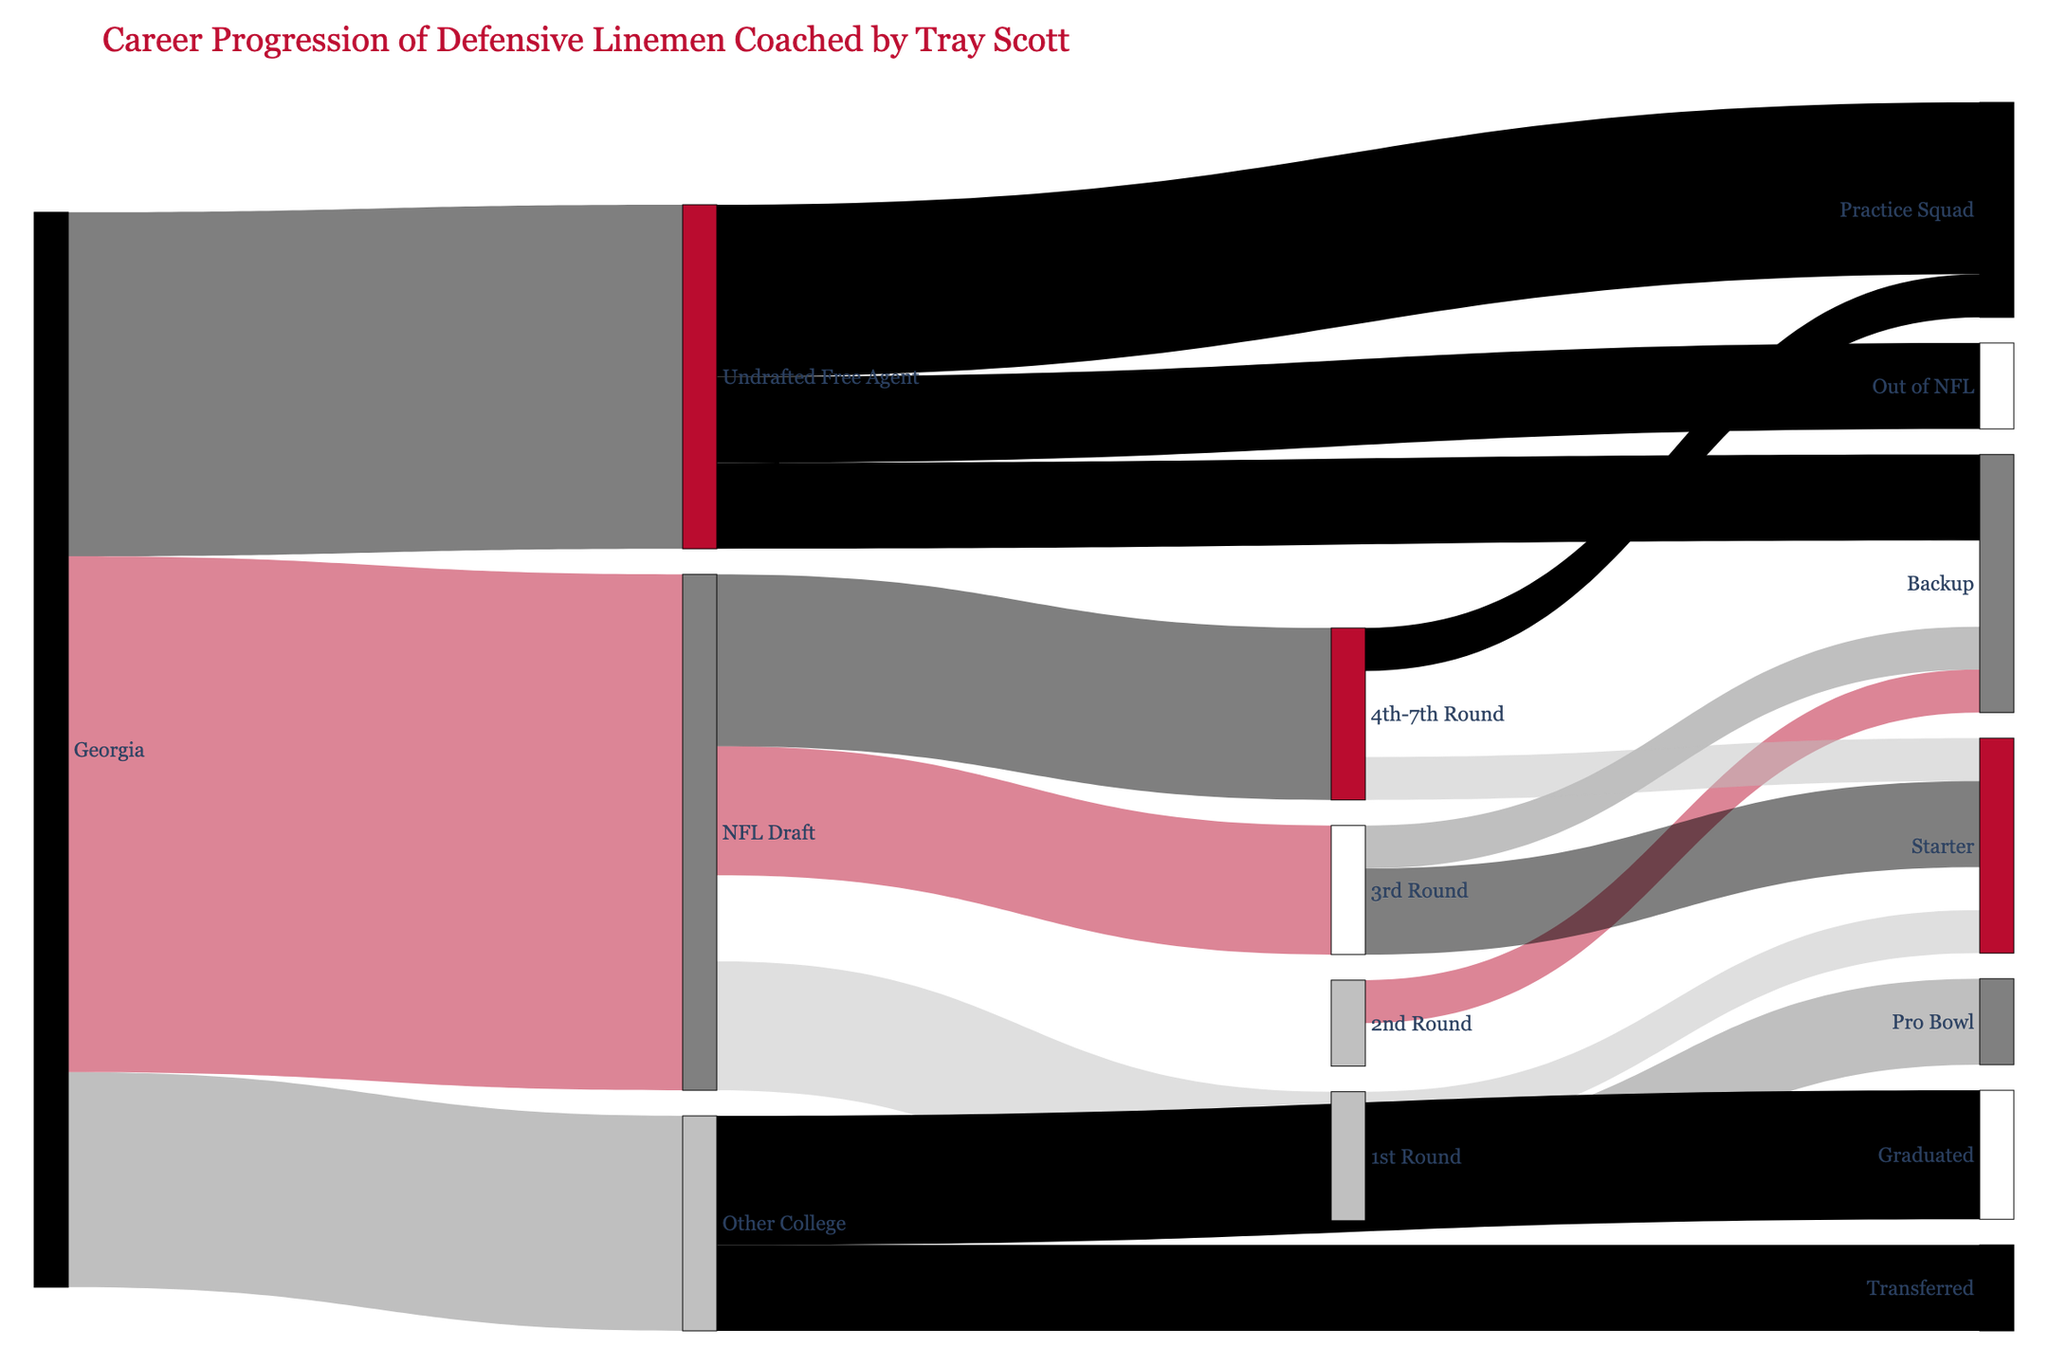What is the title of the Sankey diagram? The title of the Sankey diagram is located at the top in large font, which reads "Career Progression of Defensive Linemen Coached by Tray Scott."
Answer: Career Progression of Defensive Linemen Coached by Tray Scott From the Georgia node, which path has the highest number of defensive linemen? By looking at the values connected to the Georgia node, the largest value is 12, which goes to the NFL Draft.
Answer: NFL Draft How many total defensive linemen have moved from Georgia to the NFL, including both drafted and undrafted free agents? Total defensive linemen is the sum of those who were drafted (12) and those who became undrafted free agents (8): 12 + 8 = 20.
Answer: 20 Out of the players who were NFL Draft picks, which draft rounds had the equal number of defensive linemen? By examining the paths from the NFL Draft node to the draft rounds, both the 3rd Round and 1st Round have 3 defensive linemen each.
Answer: 1st Round and 3rd Round How many defensive linemen from the NFL Draft ultimately became Pro Bowl players? Follow the path from the NFL Draft to the 1st Round (3 players), then see how many became Pro Bowl players, which is 2.
Answer: 2 Among the undrafted free agents, which post-career path (Backup, Practice Squad, Out of NFL) has the highest number of players? Reviewing the paths starting from Undrafted Free Agent, the highest value is associated with Practice Squad with 4 players.
Answer: Practice Squad How many defensive linemen from Georgia transferred to other colleges? Looking at the path from Georgia to Other College, there are 5 defensive linemen. Then, seeing that 2 of those transferred.
Answer: 2 Which career progression has the smallest number of defensive linemen from the initial Georgia node and where do they end up? From the initial Georgia node, the smallest number is 5 defensive linemen who go to Other College, and within this, some of them transferred and graduated.
Answer: Transferred and Graduated What is the combined total of Georgia defensive linemen who ended up as Starters in the NFL? By summing up all the connections leading to Starter: 1st Round (1), 2nd Round (1), 3rd Round (2), 4th-7th Round (1). Total: 1 + 1 + 2 + 1 = 5.
Answer: 5 Which is greater: the number of undrafted free agents who ended up in the Practice Squad or the number of drafted players in the 4th-7th Round? The number of undrafted free agents in the Practice Squad is 4, while the number of drafted players in the 4th-7th Round is 4 as well.
Answer: They are equal 